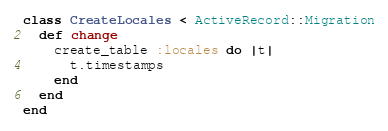<code> <loc_0><loc_0><loc_500><loc_500><_Ruby_>class CreateLocales < ActiveRecord::Migration
  def change
    create_table :locales do |t|
      t.timestamps
    end
  end
end
</code> 